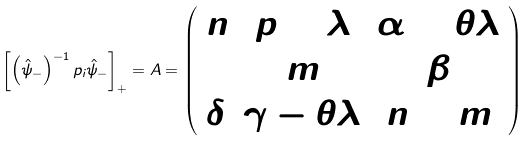Convert formula to latex. <formula><loc_0><loc_0><loc_500><loc_500>\left [ \left ( \hat { \psi } _ { - } \right ) ^ { - 1 } p _ { i } \hat { \psi } _ { - } \right ] _ { + } = A = \left ( \begin{array} { c c c } n & p + \lambda & \alpha + \theta \lambda \\ 1 & m & \beta \\ \delta & \gamma - \theta \lambda & n + m \end{array} \right )</formula> 